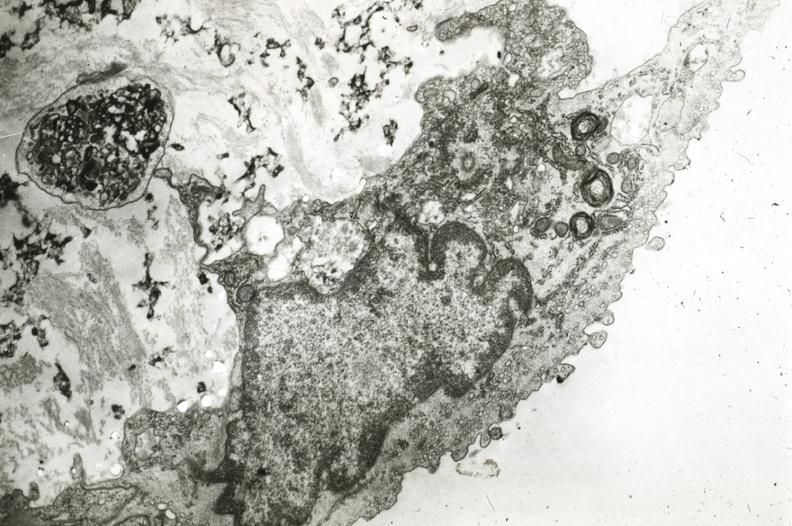does this image show endothelium with myelin bodies precipitated lipid in interstitial space?
Answer the question using a single word or phrase. Yes 